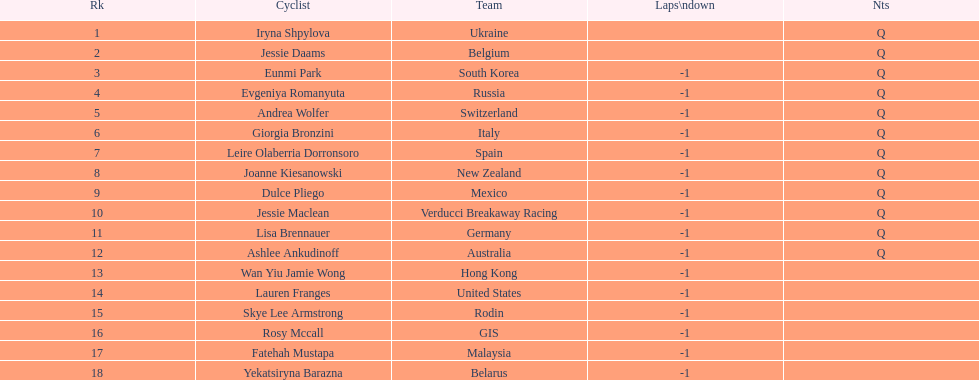Who was the one to finish before jessie maclean in the competition? Dulce Pliego. 